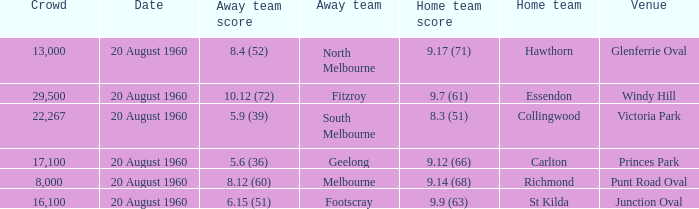What is the venue when Geelong is the away team? Princes Park. Parse the table in full. {'header': ['Crowd', 'Date', 'Away team score', 'Away team', 'Home team score', 'Home team', 'Venue'], 'rows': [['13,000', '20 August 1960', '8.4 (52)', 'North Melbourne', '9.17 (71)', 'Hawthorn', 'Glenferrie Oval'], ['29,500', '20 August 1960', '10.12 (72)', 'Fitzroy', '9.7 (61)', 'Essendon', 'Windy Hill'], ['22,267', '20 August 1960', '5.9 (39)', 'South Melbourne', '8.3 (51)', 'Collingwood', 'Victoria Park'], ['17,100', '20 August 1960', '5.6 (36)', 'Geelong', '9.12 (66)', 'Carlton', 'Princes Park'], ['8,000', '20 August 1960', '8.12 (60)', 'Melbourne', '9.14 (68)', 'Richmond', 'Punt Road Oval'], ['16,100', '20 August 1960', '6.15 (51)', 'Footscray', '9.9 (63)', 'St Kilda', 'Junction Oval']]} 